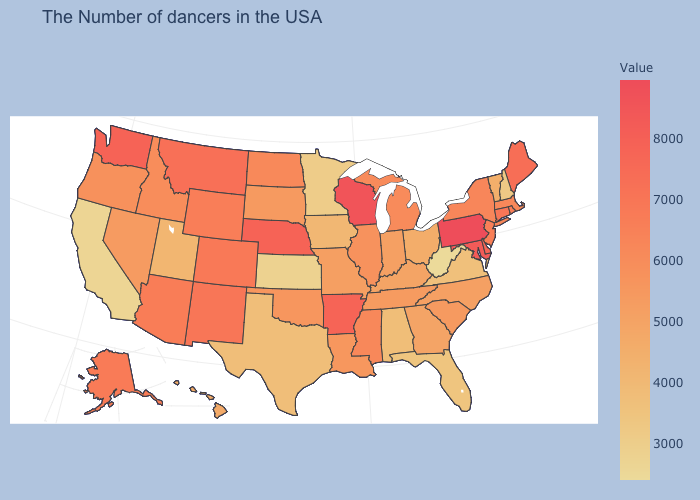Does the map have missing data?
Give a very brief answer. No. Among the states that border South Dakota , which have the lowest value?
Answer briefly. Minnesota. Which states have the lowest value in the South?
Concise answer only. West Virginia. Among the states that border Indiana , which have the highest value?
Keep it brief. Michigan. Is the legend a continuous bar?
Give a very brief answer. Yes. Among the states that border Washington , does Oregon have the highest value?
Write a very short answer. No. Which states have the lowest value in the MidWest?
Concise answer only. Kansas. Does Nebraska have the lowest value in the USA?
Answer briefly. No. 